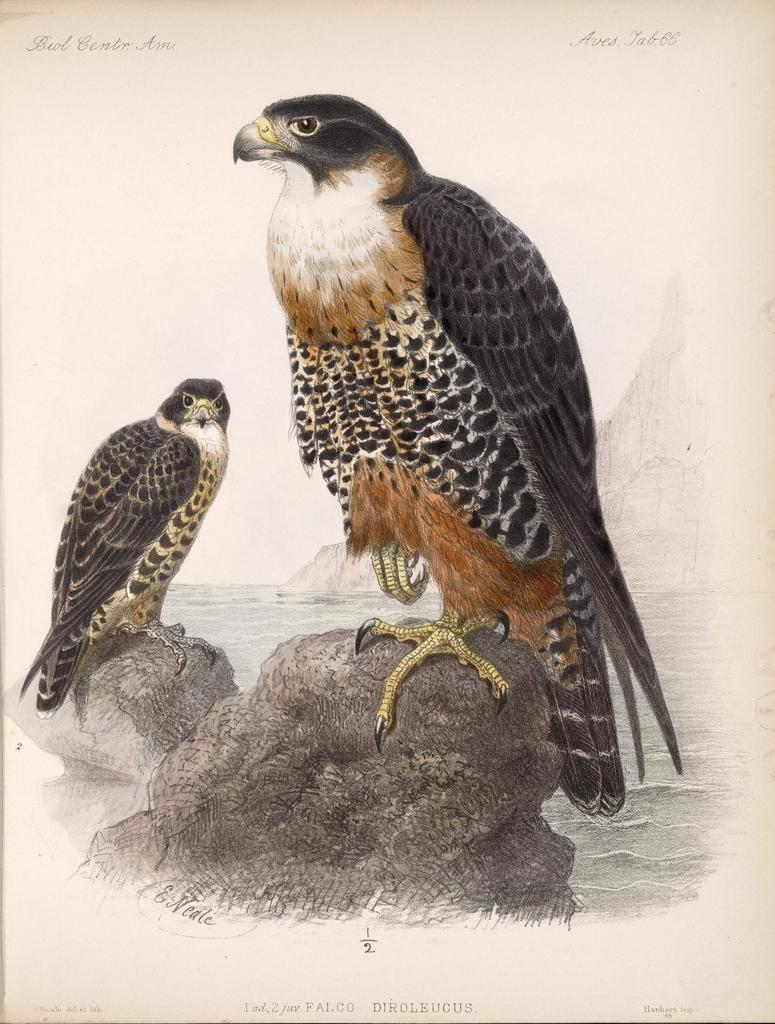What is featured on the poster in the image? Unfortunately, the facts provided do not specify what is on the poster. However, we can confirm that there is a poster present in the image. What are the birds doing in the image? The two birds are sitting on stones in the image. What can be read or seen in the text in the image? The facts provided do not specify the content of the text. However, we can confirm that there is text visible in the image. What is the water in the image? The facts provided do not specify the type of water. However, we can confirm that there is water visible in the image. What is the landscape feature in the background of the image? There are mountains visible in the background of the image. What type of screw is being used to hold the donkey in place in the image? There is no donkey present in the image, and therefore no screws or any related actions can be observed. 